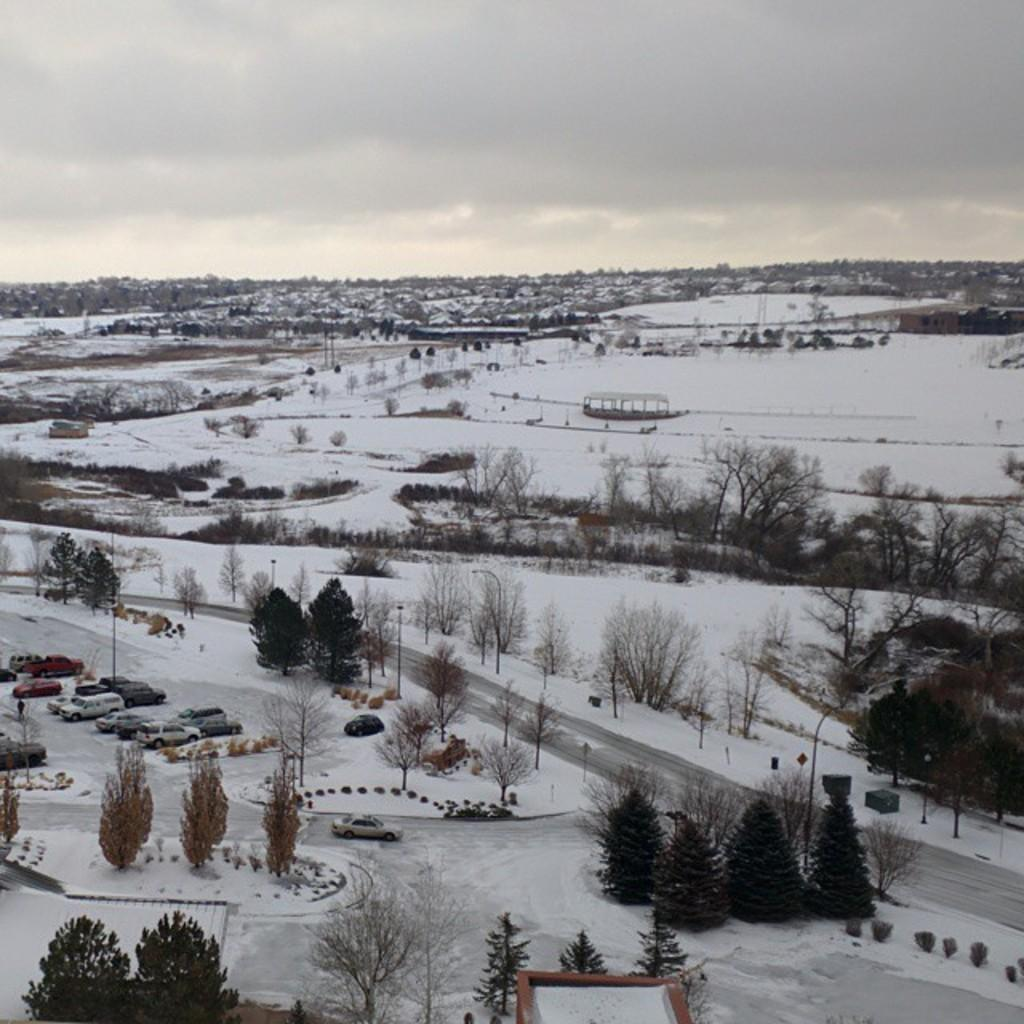What type of natural elements can be seen in the image? There are many trees in the image. What type of man-made structure is present in the image? There is a road in the image. What type of transportation is visible in the image? There are vehicles in the image. What is the weather condition in the image? The scene is covered with snow. What is visible in the background of the image? There is sky visible in the background of the image. Can you tell me which uncle is driving the car in the image? There is no uncle driving a car in the image; it only shows vehicles in a snowy scene. What type of maid is cleaning the snow off the trees in the image? There is no maid present in the image; it only shows trees covered in snow. 